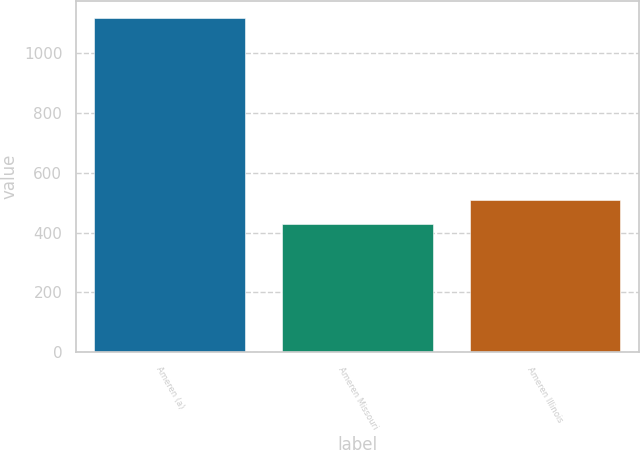Convert chart to OTSL. <chart><loc_0><loc_0><loc_500><loc_500><bar_chart><fcel>Ameren (a)<fcel>Ameren Missouri<fcel>Ameren Illinois<nl><fcel>1120<fcel>430<fcel>509<nl></chart> 